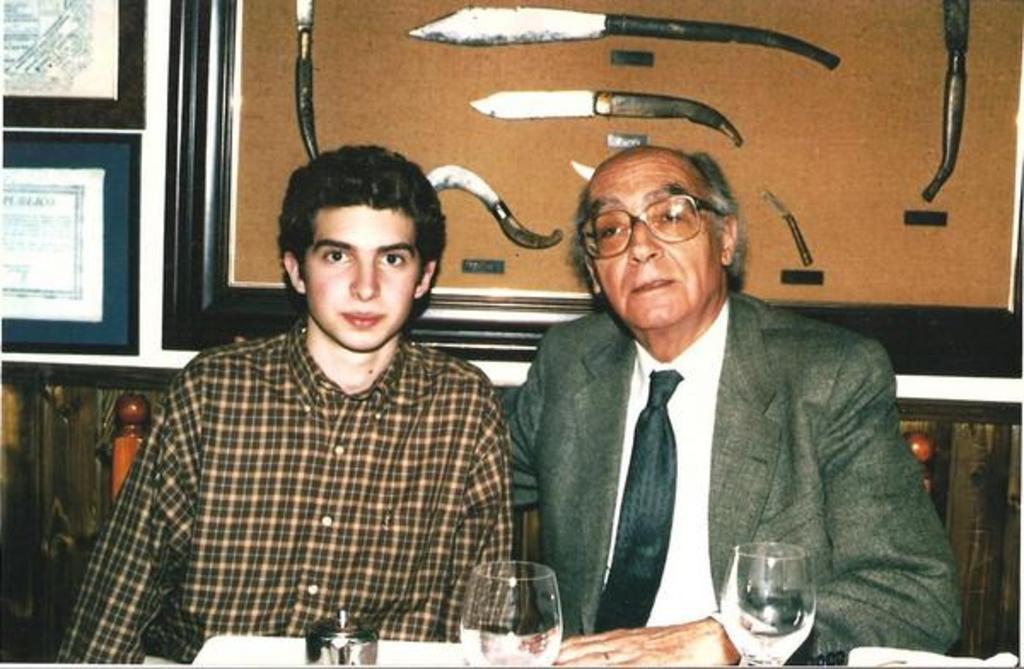Please provide a concise description of this image. In this picture we can see two men, in front of them we can find few glasses and other things, behind them we can see few knives and other tools, also we can see few frames on the wall. 